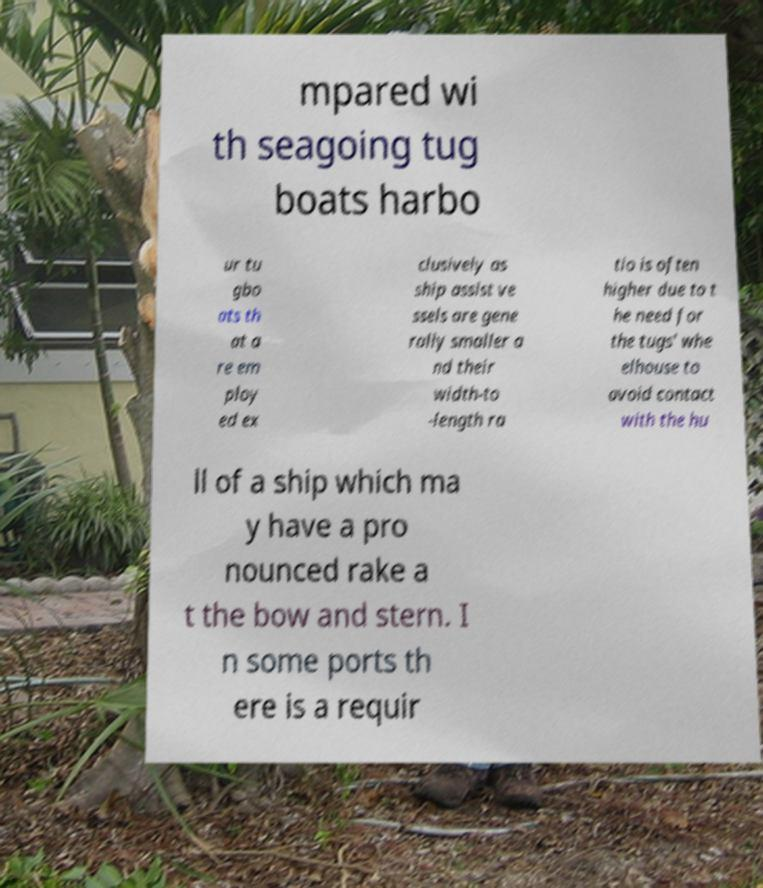There's text embedded in this image that I need extracted. Can you transcribe it verbatim? mpared wi th seagoing tug boats harbo ur tu gbo ats th at a re em ploy ed ex clusively as ship assist ve ssels are gene rally smaller a nd their width-to -length ra tio is often higher due to t he need for the tugs' whe elhouse to avoid contact with the hu ll of a ship which ma y have a pro nounced rake a t the bow and stern. I n some ports th ere is a requir 